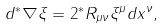Convert formula to latex. <formula><loc_0><loc_0><loc_500><loc_500>d ^ { * } \nabla \xi = 2 ^ { * } R _ { \mu \nu } \xi ^ { \mu } d x ^ { \nu } ,</formula> 